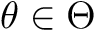<formula> <loc_0><loc_0><loc_500><loc_500>\theta \in \Theta</formula> 